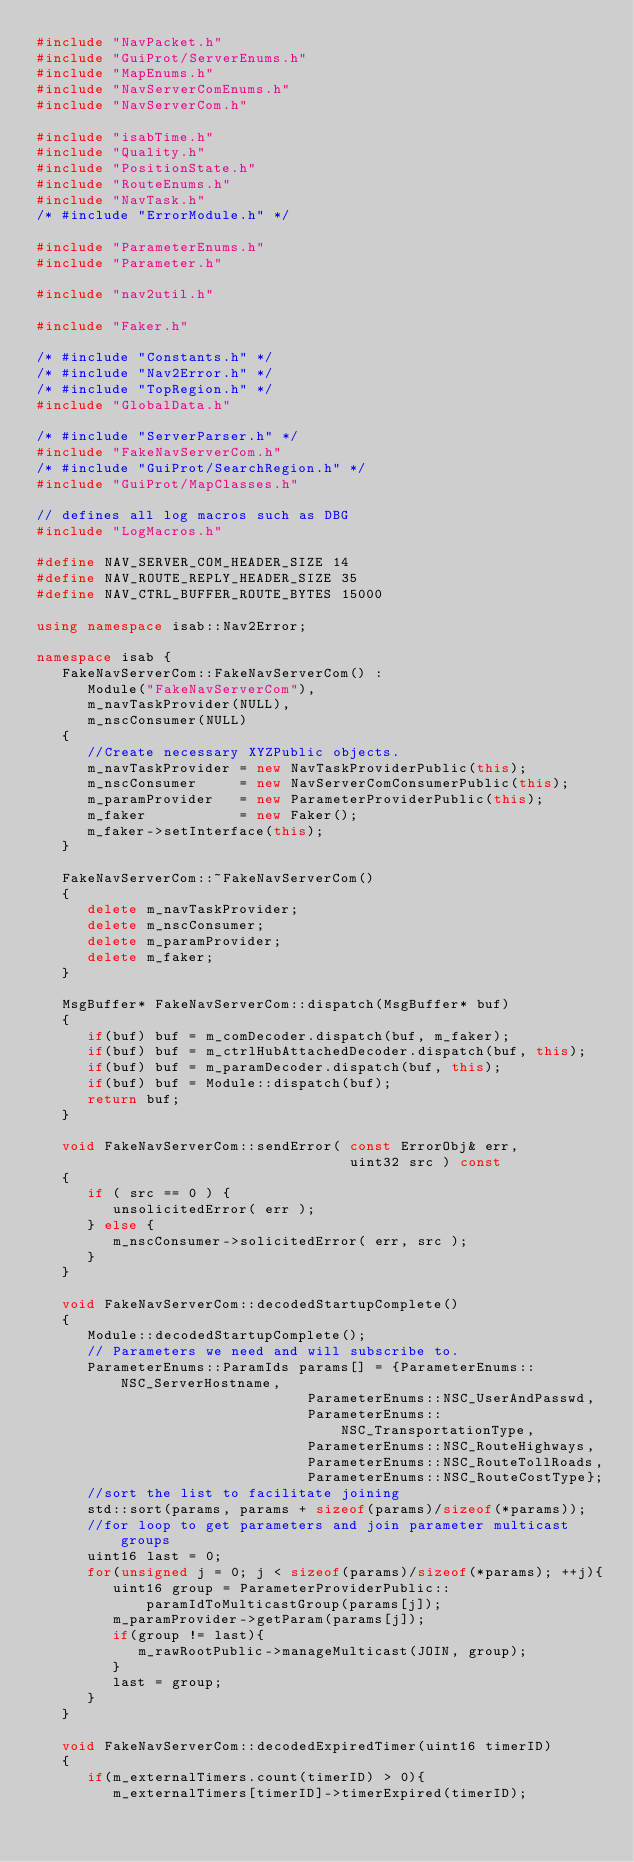Convert code to text. <code><loc_0><loc_0><loc_500><loc_500><_C++_>#include "NavPacket.h"
#include "GuiProt/ServerEnums.h"
#include "MapEnums.h"
#include "NavServerComEnums.h"
#include "NavServerCom.h"

#include "isabTime.h"
#include "Quality.h"
#include "PositionState.h"
#include "RouteEnums.h"
#include "NavTask.h"
/* #include "ErrorModule.h" */

#include "ParameterEnums.h"
#include "Parameter.h"

#include "nav2util.h"

#include "Faker.h"

/* #include "Constants.h" */
/* #include "Nav2Error.h" */
/* #include "TopRegion.h" */
#include "GlobalData.h"

/* #include "ServerParser.h" */
#include "FakeNavServerCom.h"
/* #include "GuiProt/SearchRegion.h" */
#include "GuiProt/MapClasses.h"

// defines all log macros such as DBG
#include "LogMacros.h"

#define NAV_SERVER_COM_HEADER_SIZE 14
#define NAV_ROUTE_REPLY_HEADER_SIZE 35
#define NAV_CTRL_BUFFER_ROUTE_BYTES 15000

using namespace isab::Nav2Error;

namespace isab {
   FakeNavServerCom::FakeNavServerCom() :
      Module("FakeNavServerCom"),
      m_navTaskProvider(NULL), 
      m_nscConsumer(NULL)
   {
      //Create necessary XYZPublic objects.
      m_navTaskProvider = new NavTaskProviderPublic(this);
      m_nscConsumer     = new NavServerComConsumerPublic(this);
      m_paramProvider   = new ParameterProviderPublic(this);
      m_faker           = new Faker();
      m_faker->setInterface(this);
   }

   FakeNavServerCom::~FakeNavServerCom()
   {
      delete m_navTaskProvider;
      delete m_nscConsumer;
      delete m_paramProvider;
      delete m_faker;
   }

   MsgBuffer* FakeNavServerCom::dispatch(MsgBuffer* buf)
   {
      if(buf) buf = m_comDecoder.dispatch(buf, m_faker);
      if(buf) buf = m_ctrlHubAttachedDecoder.dispatch(buf, this);
      if(buf) buf = m_paramDecoder.dispatch(buf, this);
      if(buf) buf = Module::dispatch(buf);
      return buf;
   }

   void FakeNavServerCom::sendError( const ErrorObj& err, 
                                     uint32 src ) const
   {
      if ( src == 0 ) {
         unsolicitedError( err );
      } else {
         m_nscConsumer->solicitedError( err, src );
      }
   }

   void FakeNavServerCom::decodedStartupComplete()
   {
      Module::decodedStartupComplete();
      // Parameters we need and will subscribe to.
      ParameterEnums::ParamIds params[] = {ParameterEnums::NSC_ServerHostname, 
                                ParameterEnums::NSC_UserAndPasswd, 
                                ParameterEnums::NSC_TransportationType,
                                ParameterEnums::NSC_RouteHighways,
                                ParameterEnums::NSC_RouteTollRoads,
                                ParameterEnums::NSC_RouteCostType};
      //sort the list to facilitate joining
      std::sort(params, params + sizeof(params)/sizeof(*params));
      //for loop to get parameters and join parameter multicast groups
      uint16 last = 0;
      for(unsigned j = 0; j < sizeof(params)/sizeof(*params); ++j){
         uint16 group = ParameterProviderPublic::paramIdToMulticastGroup(params[j]);
         m_paramProvider->getParam(params[j]);
         if(group != last){
            m_rawRootPublic->manageMulticast(JOIN, group);
         }
         last = group;
      }
   }

   void FakeNavServerCom::decodedExpiredTimer(uint16 timerID)
   {
      if(m_externalTimers.count(timerID) > 0){
         m_externalTimers[timerID]->timerExpired(timerID);</code> 